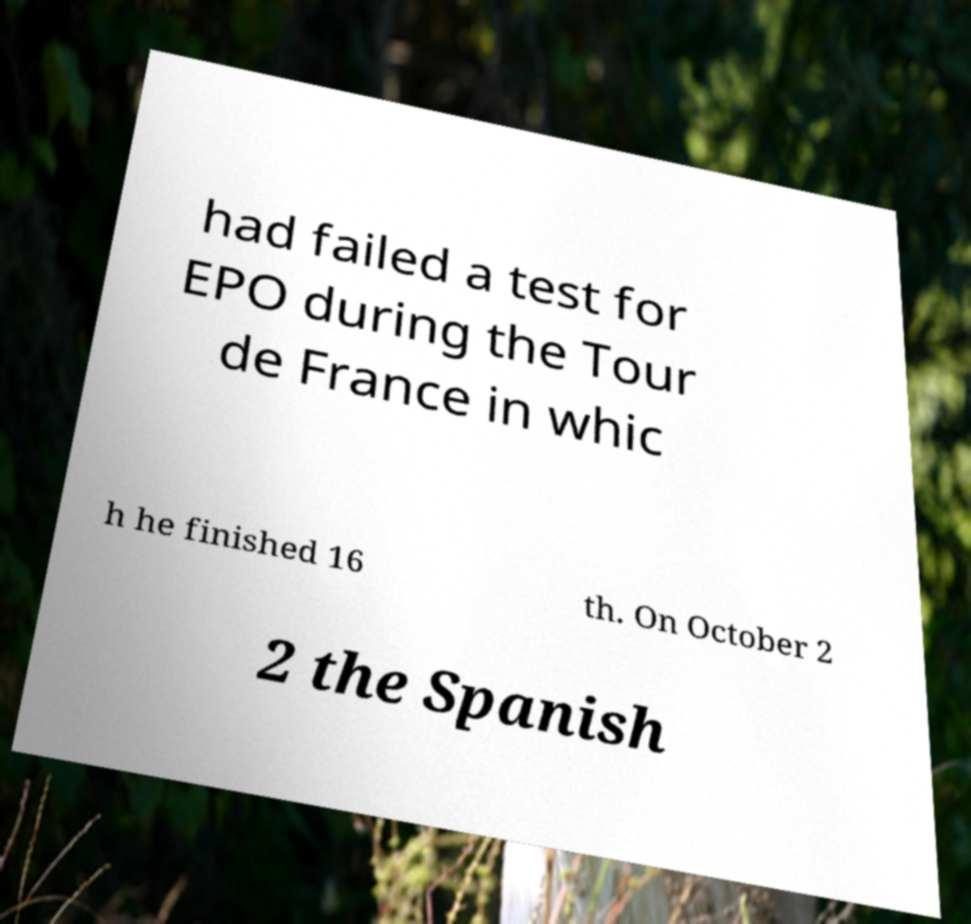Please identify and transcribe the text found in this image. had failed a test for EPO during the Tour de France in whic h he finished 16 th. On October 2 2 the Spanish 